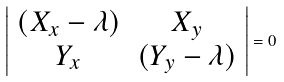<formula> <loc_0><loc_0><loc_500><loc_500>\left | \begin{array} { c c } ( X _ { x } - \lambda ) & X _ { y } \\ Y _ { x } & ( Y _ { y } - \lambda ) \end{array} \right | = 0</formula> 